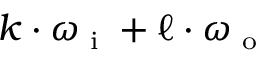Convert formula to latex. <formula><loc_0><loc_0><loc_500><loc_500>k \cdot \omega _ { i } + \ell \cdot \omega _ { o }</formula> 